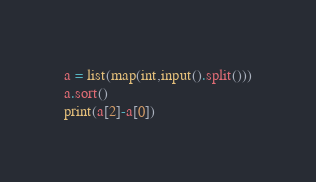Convert code to text. <code><loc_0><loc_0><loc_500><loc_500><_Python_>a = list(map(int,input().split()))
a.sort()
print(a[2]-a[0])  </code> 